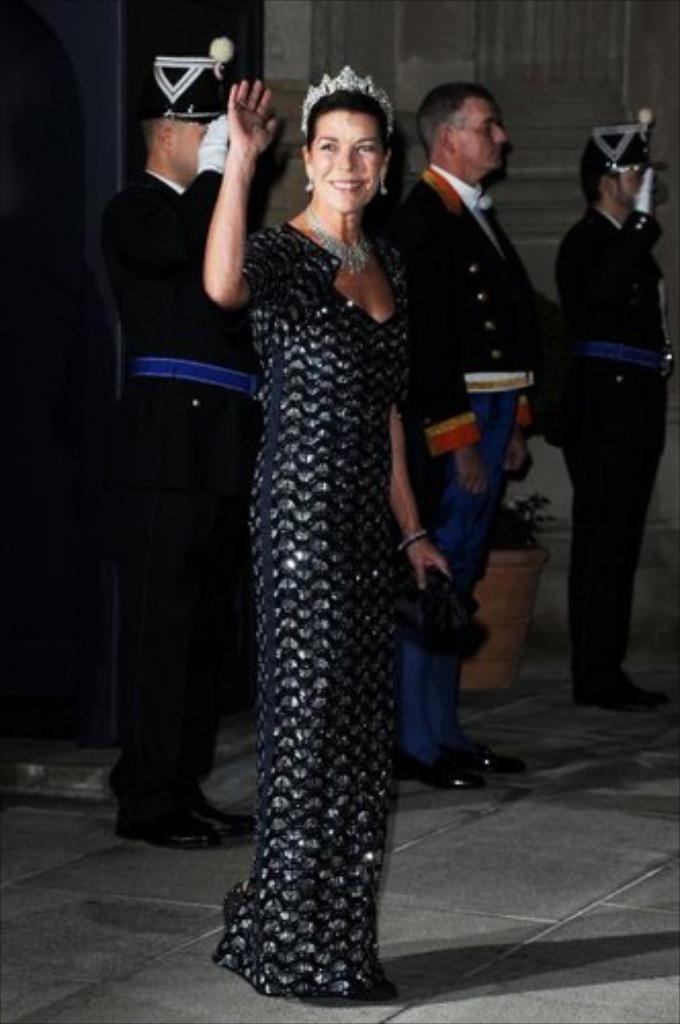Describe this image in one or two sentences. In this image we can see few people standing on the floor, a woman is holding an object, behind her there are few people wearing uniform and there is a potted plant and a wall in the background. 